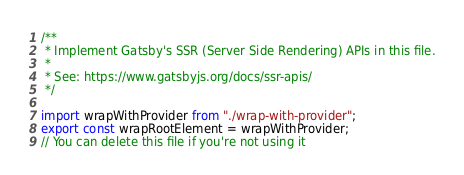<code> <loc_0><loc_0><loc_500><loc_500><_JavaScript_>/**
 * Implement Gatsby's SSR (Server Side Rendering) APIs in this file.
 *
 * See: https://www.gatsbyjs.org/docs/ssr-apis/
 */

import wrapWithProvider from "./wrap-with-provider";
export const wrapRootElement = wrapWithProvider;
// You can delete this file if you're not using it
</code> 